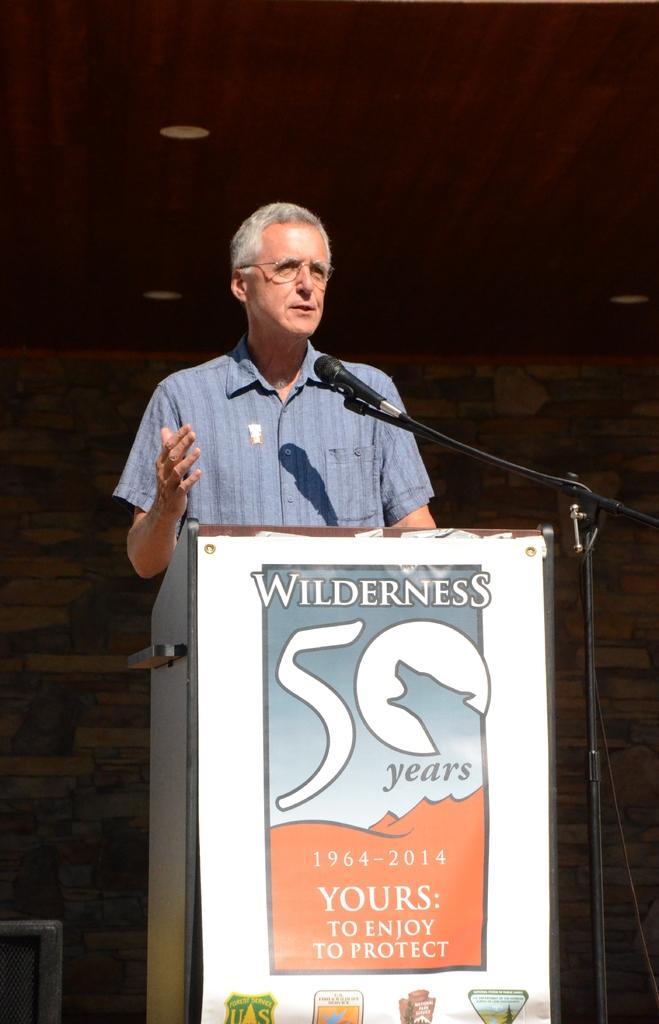Describe this image in one or two sentences. In the center of this picture we can see a person wearing shirt, standing behind the podium and seems to be talking and we can see a microphone is attached to the metal stand and we can see the text, numbers and some pictures on the poster attached to the podium. In the background we can see the roof, ceiling lights, wall and some other objects. 